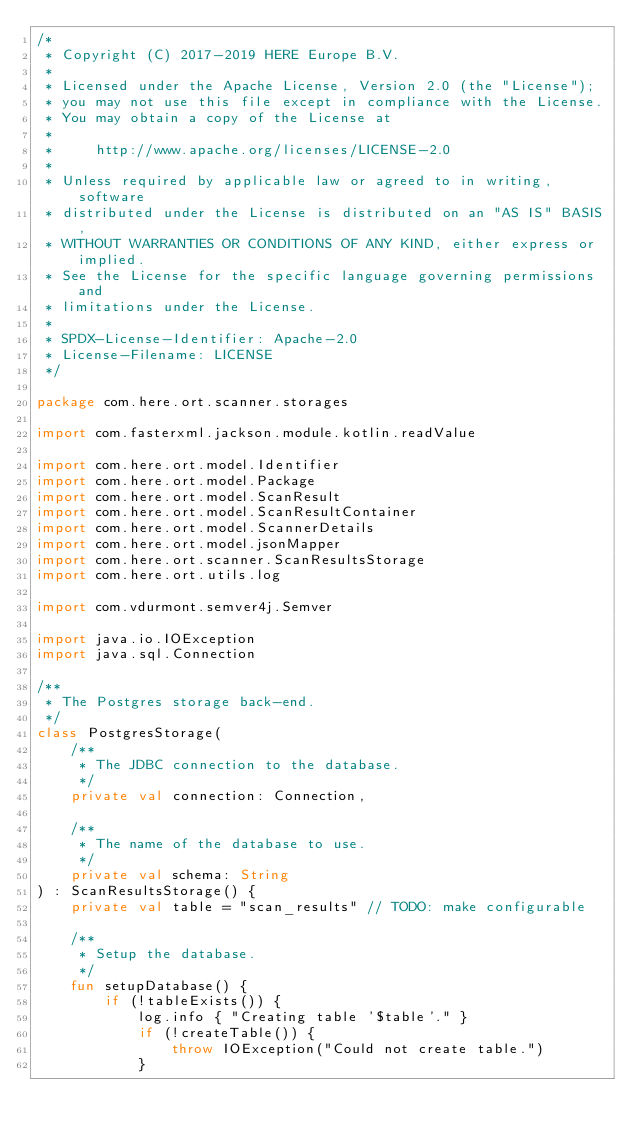<code> <loc_0><loc_0><loc_500><loc_500><_Kotlin_>/*
 * Copyright (C) 2017-2019 HERE Europe B.V.
 *
 * Licensed under the Apache License, Version 2.0 (the "License");
 * you may not use this file except in compliance with the License.
 * You may obtain a copy of the License at
 *
 *     http://www.apache.org/licenses/LICENSE-2.0
 *
 * Unless required by applicable law or agreed to in writing, software
 * distributed under the License is distributed on an "AS IS" BASIS,
 * WITHOUT WARRANTIES OR CONDITIONS OF ANY KIND, either express or implied.
 * See the License for the specific language governing permissions and
 * limitations under the License.
 *
 * SPDX-License-Identifier: Apache-2.0
 * License-Filename: LICENSE
 */

package com.here.ort.scanner.storages

import com.fasterxml.jackson.module.kotlin.readValue

import com.here.ort.model.Identifier
import com.here.ort.model.Package
import com.here.ort.model.ScanResult
import com.here.ort.model.ScanResultContainer
import com.here.ort.model.ScannerDetails
import com.here.ort.model.jsonMapper
import com.here.ort.scanner.ScanResultsStorage
import com.here.ort.utils.log

import com.vdurmont.semver4j.Semver

import java.io.IOException
import java.sql.Connection

/**
 * The Postgres storage back-end.
 */
class PostgresStorage(
    /**
     * The JDBC connection to the database.
     */
    private val connection: Connection,

    /**
     * The name of the database to use.
     */
    private val schema: String
) : ScanResultsStorage() {
    private val table = "scan_results" // TODO: make configurable

    /**
     * Setup the database.
     */
    fun setupDatabase() {
        if (!tableExists()) {
            log.info { "Creating table '$table'." }
            if (!createTable()) {
                throw IOException("Could not create table.")
            }</code> 